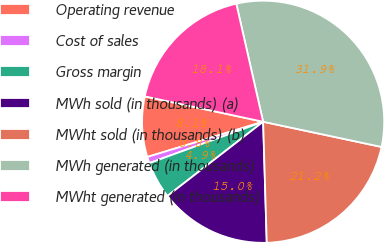<chart> <loc_0><loc_0><loc_500><loc_500><pie_chart><fcel>Operating revenue<fcel>Cost of sales<fcel>Gross margin<fcel>MWh sold (in thousands) (a)<fcel>MWht sold (in thousands) (b)<fcel>MWh generated (in thousands)<fcel>MWht generated (in thousands)<nl><fcel>8.06%<fcel>0.85%<fcel>4.95%<fcel>14.98%<fcel>21.19%<fcel>31.9%<fcel>18.08%<nl></chart> 